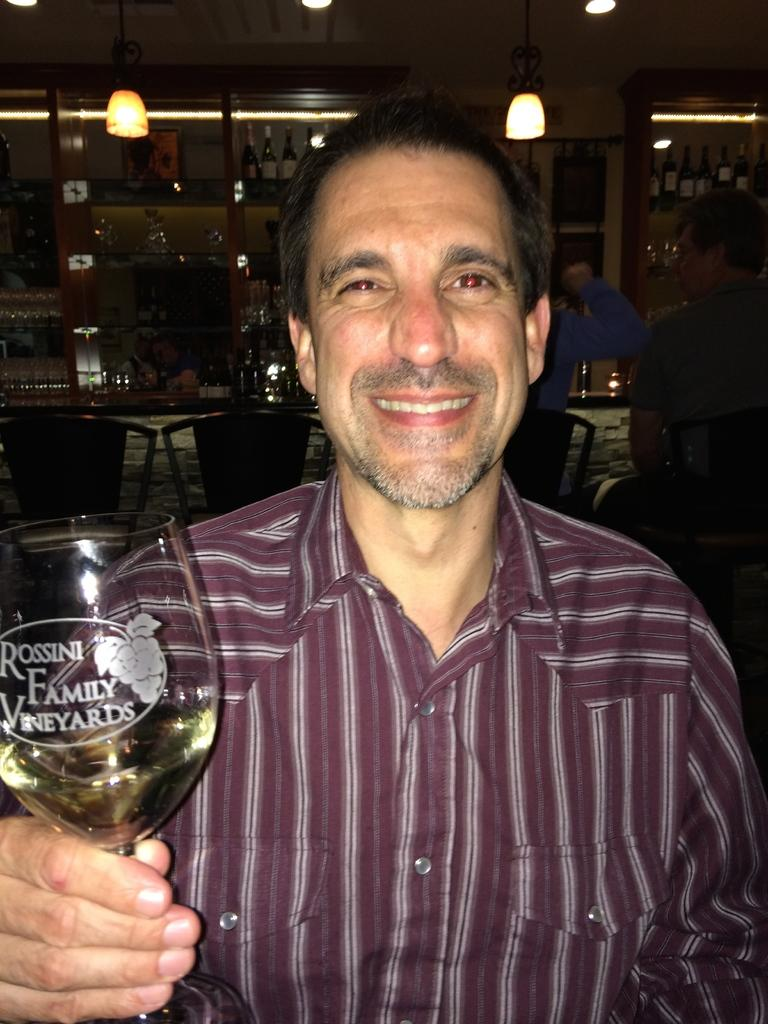Who is in the image? There is a man in the image. What is the man doing in the image? The man is posing for a picture. What is the man holding in his hand? The man is holding a glass in his hand. What can be seen at the top of the image? There are two lights at the top of the image. What is visible in the background of the image? There are wine bottles and chairs in the background of the image. What type of jam is being used to decorate the man's face in the image? There is no jam present in the image, and the man's face is not being decorated. 